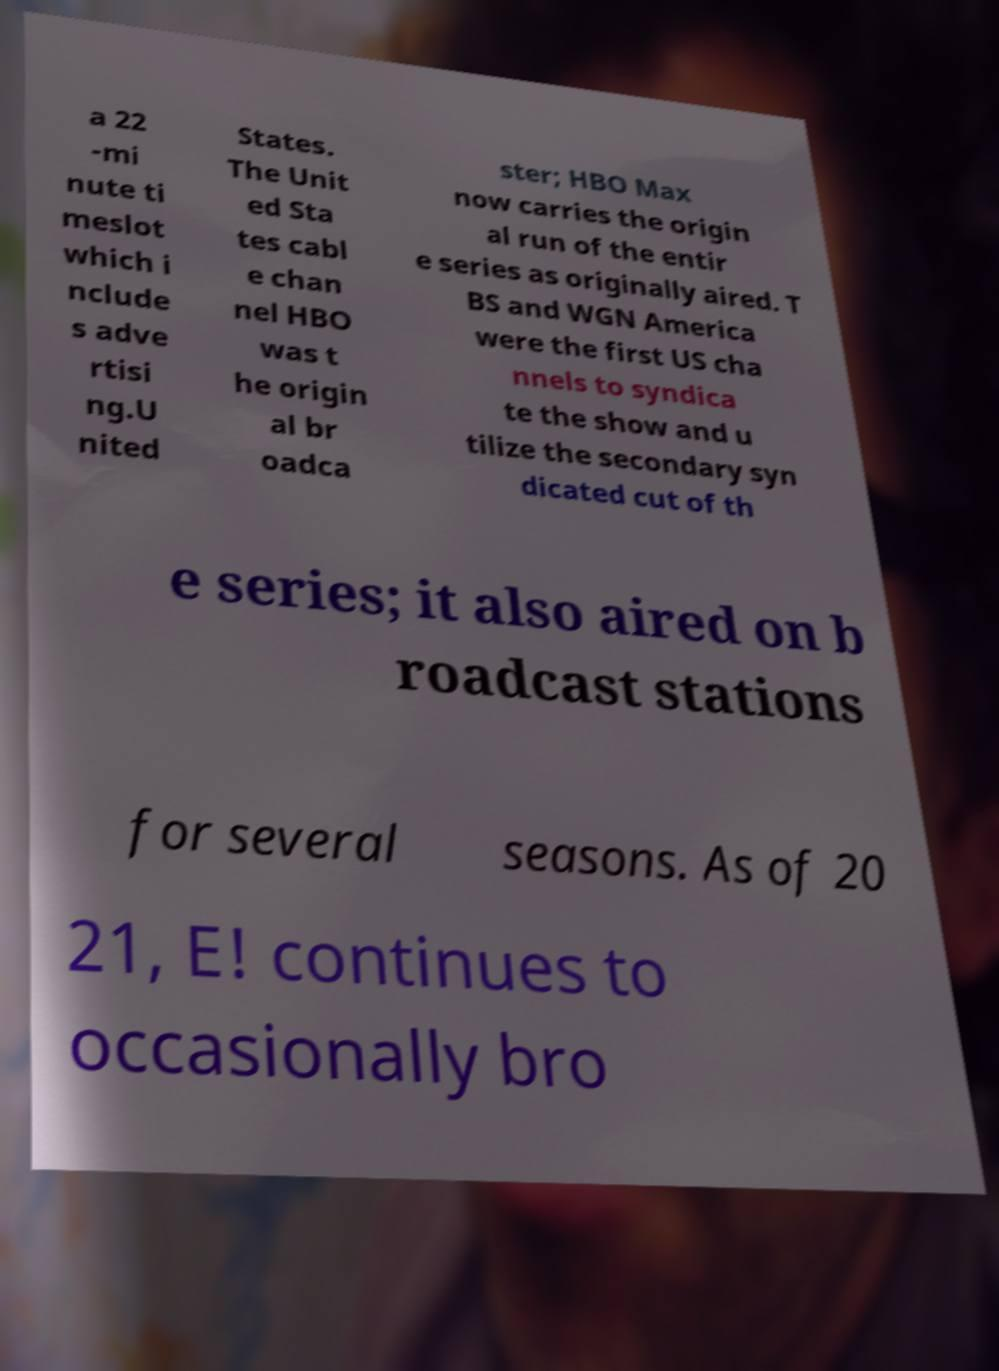Please read and relay the text visible in this image. What does it say? a 22 -mi nute ti meslot which i nclude s adve rtisi ng.U nited States. The Unit ed Sta tes cabl e chan nel HBO was t he origin al br oadca ster; HBO Max now carries the origin al run of the entir e series as originally aired. T BS and WGN America were the first US cha nnels to syndica te the show and u tilize the secondary syn dicated cut of th e series; it also aired on b roadcast stations for several seasons. As of 20 21, E! continues to occasionally bro 